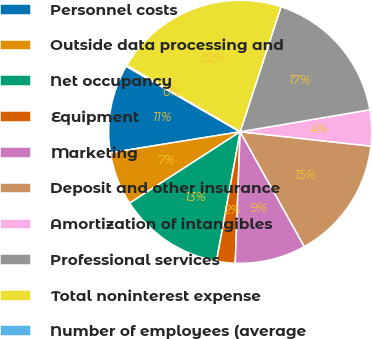<chart> <loc_0><loc_0><loc_500><loc_500><pie_chart><fcel>Personnel costs<fcel>Outside data processing and<fcel>Net occupancy<fcel>Equipment<fcel>Marketing<fcel>Deposit and other insurance<fcel>Amortization of intangibles<fcel>Professional services<fcel>Total noninterest expense<fcel>Number of employees (average<nl><fcel>10.86%<fcel>6.57%<fcel>13.0%<fcel>2.28%<fcel>8.71%<fcel>15.15%<fcel>4.42%<fcel>17.3%<fcel>21.59%<fcel>0.13%<nl></chart> 